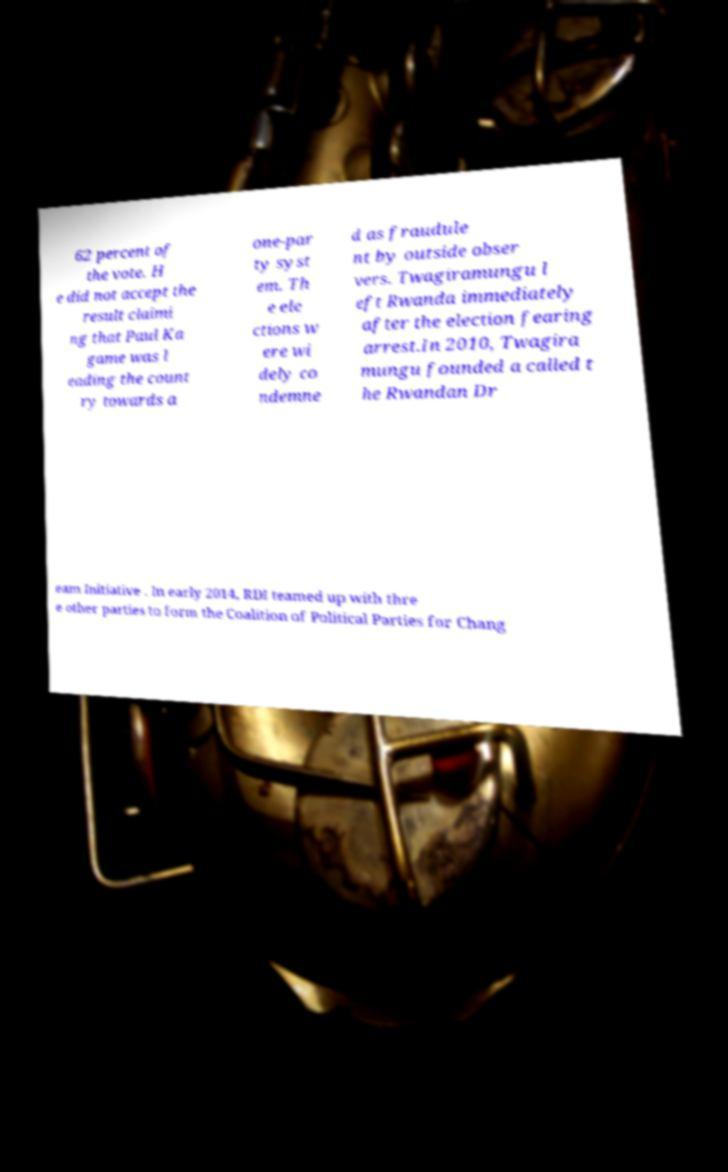Can you accurately transcribe the text from the provided image for me? 62 percent of the vote. H e did not accept the result claimi ng that Paul Ka game was l eading the count ry towards a one-par ty syst em. Th e ele ctions w ere wi dely co ndemne d as fraudule nt by outside obser vers. Twagiramungu l eft Rwanda immediately after the election fearing arrest.In 2010, Twagira mungu founded a called t he Rwandan Dr eam Initiative . In early 2014, RDI teamed up with thre e other parties to form the Coalition of Political Parties for Chang 